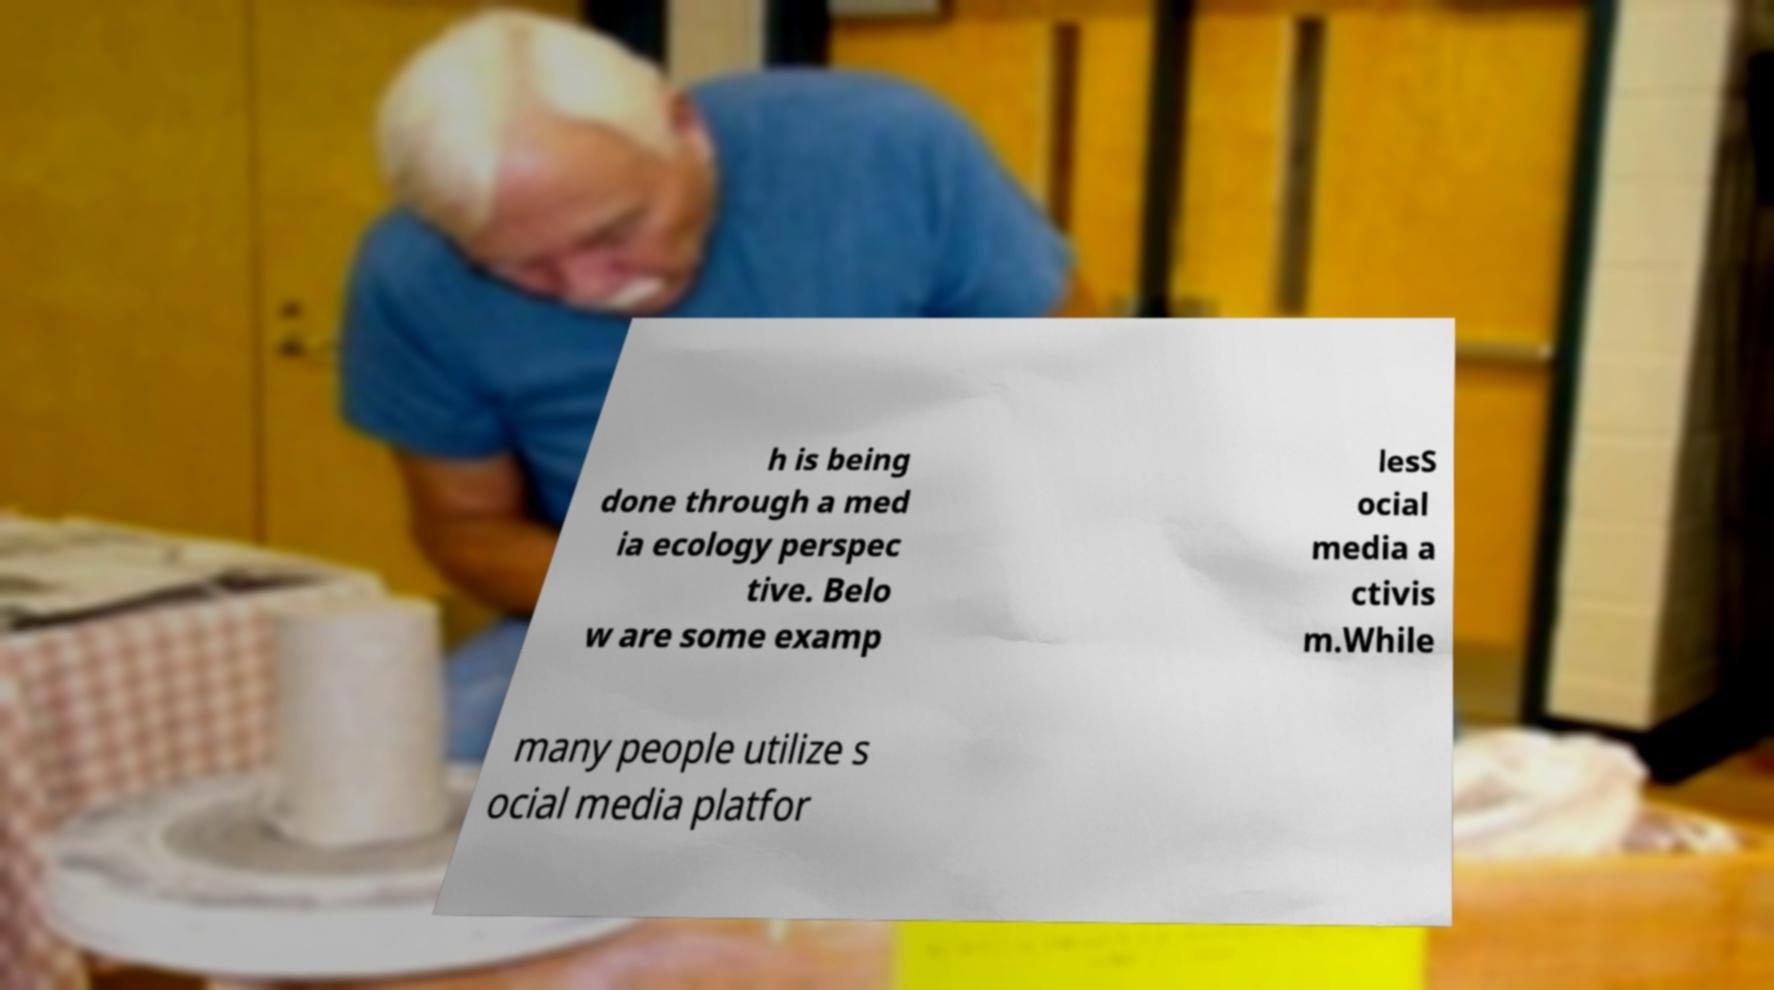For documentation purposes, I need the text within this image transcribed. Could you provide that? h is being done through a med ia ecology perspec tive. Belo w are some examp lesS ocial media a ctivis m.While many people utilize s ocial media platfor 